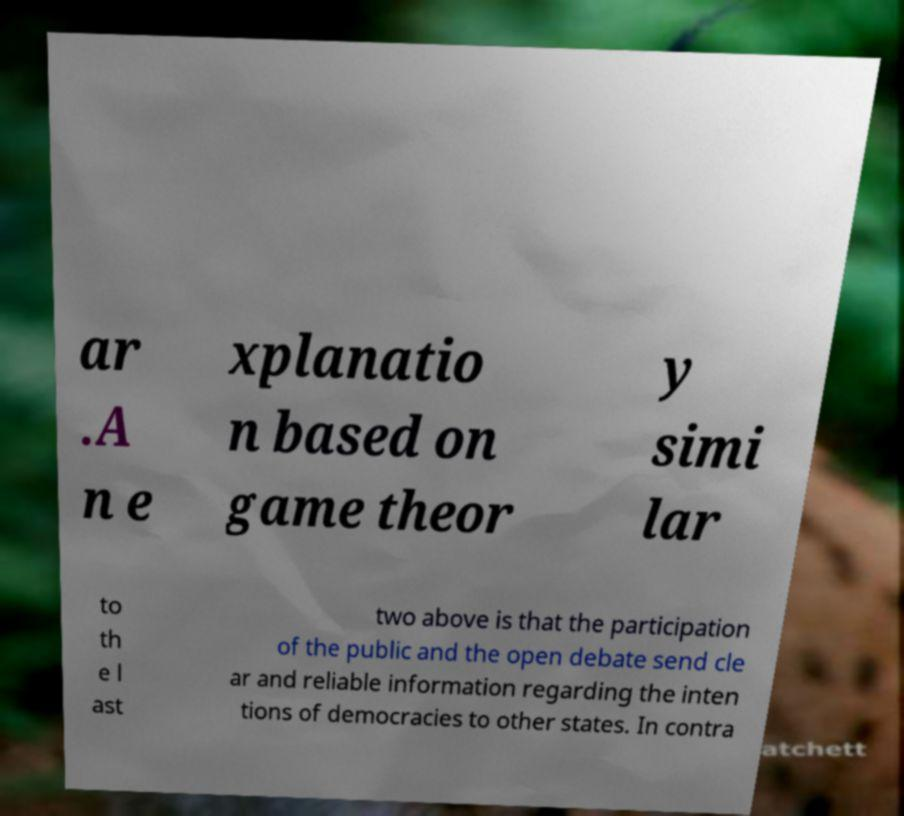Please read and relay the text visible in this image. What does it say? ar .A n e xplanatio n based on game theor y simi lar to th e l ast two above is that the participation of the public and the open debate send cle ar and reliable information regarding the inten tions of democracies to other states. In contra 